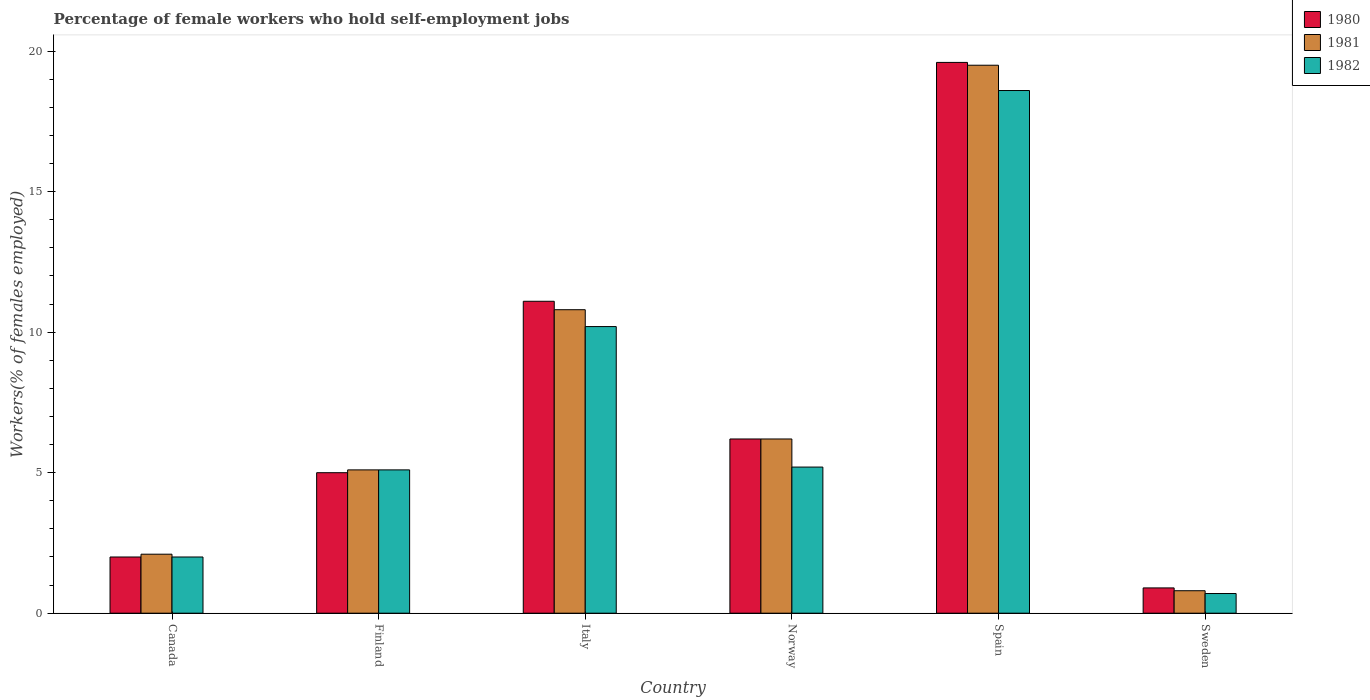How many different coloured bars are there?
Offer a terse response. 3. How many groups of bars are there?
Offer a very short reply. 6. What is the label of the 2nd group of bars from the left?
Your answer should be very brief. Finland. What is the percentage of self-employed female workers in 1982 in Sweden?
Ensure brevity in your answer.  0.7. Across all countries, what is the maximum percentage of self-employed female workers in 1980?
Provide a succinct answer. 19.6. Across all countries, what is the minimum percentage of self-employed female workers in 1982?
Keep it short and to the point. 0.7. In which country was the percentage of self-employed female workers in 1981 maximum?
Your response must be concise. Spain. In which country was the percentage of self-employed female workers in 1980 minimum?
Offer a very short reply. Sweden. What is the total percentage of self-employed female workers in 1982 in the graph?
Your answer should be compact. 41.8. What is the difference between the percentage of self-employed female workers in 1980 in Norway and that in Spain?
Your response must be concise. -13.4. What is the difference between the percentage of self-employed female workers in 1981 in Canada and the percentage of self-employed female workers in 1982 in Finland?
Your answer should be very brief. -3. What is the average percentage of self-employed female workers in 1980 per country?
Offer a terse response. 7.47. What is the difference between the percentage of self-employed female workers of/in 1980 and percentage of self-employed female workers of/in 1981 in Sweden?
Offer a very short reply. 0.1. What is the ratio of the percentage of self-employed female workers in 1980 in Canada to that in Spain?
Keep it short and to the point. 0.1. Is the percentage of self-employed female workers in 1980 in Italy less than that in Spain?
Provide a short and direct response. Yes. What is the difference between the highest and the second highest percentage of self-employed female workers in 1981?
Keep it short and to the point. -8.7. What is the difference between the highest and the lowest percentage of self-employed female workers in 1982?
Offer a very short reply. 17.9. Is the sum of the percentage of self-employed female workers in 1982 in Italy and Spain greater than the maximum percentage of self-employed female workers in 1980 across all countries?
Give a very brief answer. Yes. How many countries are there in the graph?
Provide a short and direct response. 6. Are the values on the major ticks of Y-axis written in scientific E-notation?
Your answer should be very brief. No. Does the graph contain any zero values?
Keep it short and to the point. No. How many legend labels are there?
Offer a terse response. 3. What is the title of the graph?
Provide a succinct answer. Percentage of female workers who hold self-employment jobs. What is the label or title of the Y-axis?
Your response must be concise. Workers(% of females employed). What is the Workers(% of females employed) of 1980 in Canada?
Ensure brevity in your answer.  2. What is the Workers(% of females employed) of 1981 in Canada?
Offer a very short reply. 2.1. What is the Workers(% of females employed) in 1982 in Canada?
Give a very brief answer. 2. What is the Workers(% of females employed) of 1981 in Finland?
Provide a succinct answer. 5.1. What is the Workers(% of females employed) of 1982 in Finland?
Provide a short and direct response. 5.1. What is the Workers(% of females employed) in 1980 in Italy?
Offer a very short reply. 11.1. What is the Workers(% of females employed) of 1981 in Italy?
Keep it short and to the point. 10.8. What is the Workers(% of females employed) of 1982 in Italy?
Provide a succinct answer. 10.2. What is the Workers(% of females employed) in 1980 in Norway?
Give a very brief answer. 6.2. What is the Workers(% of females employed) of 1981 in Norway?
Your response must be concise. 6.2. What is the Workers(% of females employed) in 1982 in Norway?
Keep it short and to the point. 5.2. What is the Workers(% of females employed) in 1980 in Spain?
Ensure brevity in your answer.  19.6. What is the Workers(% of females employed) of 1981 in Spain?
Your response must be concise. 19.5. What is the Workers(% of females employed) in 1982 in Spain?
Provide a succinct answer. 18.6. What is the Workers(% of females employed) of 1980 in Sweden?
Offer a terse response. 0.9. What is the Workers(% of females employed) in 1981 in Sweden?
Provide a short and direct response. 0.8. What is the Workers(% of females employed) in 1982 in Sweden?
Ensure brevity in your answer.  0.7. Across all countries, what is the maximum Workers(% of females employed) in 1980?
Keep it short and to the point. 19.6. Across all countries, what is the maximum Workers(% of females employed) in 1981?
Provide a succinct answer. 19.5. Across all countries, what is the maximum Workers(% of females employed) in 1982?
Your answer should be very brief. 18.6. Across all countries, what is the minimum Workers(% of females employed) in 1980?
Your answer should be compact. 0.9. Across all countries, what is the minimum Workers(% of females employed) of 1981?
Provide a succinct answer. 0.8. Across all countries, what is the minimum Workers(% of females employed) of 1982?
Give a very brief answer. 0.7. What is the total Workers(% of females employed) in 1980 in the graph?
Your answer should be compact. 44.8. What is the total Workers(% of females employed) of 1981 in the graph?
Offer a very short reply. 44.5. What is the total Workers(% of females employed) in 1982 in the graph?
Keep it short and to the point. 41.8. What is the difference between the Workers(% of females employed) of 1980 in Canada and that in Finland?
Your response must be concise. -3. What is the difference between the Workers(% of females employed) of 1982 in Canada and that in Finland?
Provide a short and direct response. -3.1. What is the difference between the Workers(% of females employed) of 1980 in Canada and that in Italy?
Your answer should be compact. -9.1. What is the difference between the Workers(% of females employed) of 1982 in Canada and that in Italy?
Your answer should be compact. -8.2. What is the difference between the Workers(% of females employed) of 1982 in Canada and that in Norway?
Ensure brevity in your answer.  -3.2. What is the difference between the Workers(% of females employed) in 1980 in Canada and that in Spain?
Offer a very short reply. -17.6. What is the difference between the Workers(% of females employed) of 1981 in Canada and that in Spain?
Provide a succinct answer. -17.4. What is the difference between the Workers(% of females employed) of 1982 in Canada and that in Spain?
Give a very brief answer. -16.6. What is the difference between the Workers(% of females employed) in 1980 in Canada and that in Sweden?
Provide a short and direct response. 1.1. What is the difference between the Workers(% of females employed) of 1981 in Canada and that in Sweden?
Provide a short and direct response. 1.3. What is the difference between the Workers(% of females employed) of 1982 in Canada and that in Sweden?
Provide a succinct answer. 1.3. What is the difference between the Workers(% of females employed) of 1980 in Finland and that in Italy?
Provide a succinct answer. -6.1. What is the difference between the Workers(% of females employed) in 1980 in Finland and that in Norway?
Give a very brief answer. -1.2. What is the difference between the Workers(% of females employed) in 1980 in Finland and that in Spain?
Your response must be concise. -14.6. What is the difference between the Workers(% of females employed) of 1981 in Finland and that in Spain?
Give a very brief answer. -14.4. What is the difference between the Workers(% of females employed) of 1982 in Finland and that in Sweden?
Make the answer very short. 4.4. What is the difference between the Workers(% of females employed) of 1980 in Italy and that in Norway?
Keep it short and to the point. 4.9. What is the difference between the Workers(% of females employed) in 1981 in Italy and that in Norway?
Ensure brevity in your answer.  4.6. What is the difference between the Workers(% of females employed) in 1981 in Italy and that in Spain?
Make the answer very short. -8.7. What is the difference between the Workers(% of females employed) of 1982 in Italy and that in Sweden?
Make the answer very short. 9.5. What is the difference between the Workers(% of females employed) of 1981 in Norway and that in Spain?
Offer a terse response. -13.3. What is the difference between the Workers(% of females employed) of 1982 in Norway and that in Spain?
Keep it short and to the point. -13.4. What is the difference between the Workers(% of females employed) of 1980 in Norway and that in Sweden?
Your response must be concise. 5.3. What is the difference between the Workers(% of females employed) of 1981 in Norway and that in Sweden?
Keep it short and to the point. 5.4. What is the difference between the Workers(% of females employed) in 1982 in Norway and that in Sweden?
Give a very brief answer. 4.5. What is the difference between the Workers(% of females employed) in 1982 in Spain and that in Sweden?
Keep it short and to the point. 17.9. What is the difference between the Workers(% of females employed) of 1980 in Canada and the Workers(% of females employed) of 1982 in Finland?
Your answer should be compact. -3.1. What is the difference between the Workers(% of females employed) in 1981 in Canada and the Workers(% of females employed) in 1982 in Finland?
Give a very brief answer. -3. What is the difference between the Workers(% of females employed) of 1980 in Canada and the Workers(% of females employed) of 1981 in Italy?
Your response must be concise. -8.8. What is the difference between the Workers(% of females employed) of 1980 in Canada and the Workers(% of females employed) of 1982 in Italy?
Ensure brevity in your answer.  -8.2. What is the difference between the Workers(% of females employed) in 1981 in Canada and the Workers(% of females employed) in 1982 in Italy?
Ensure brevity in your answer.  -8.1. What is the difference between the Workers(% of females employed) of 1980 in Canada and the Workers(% of females employed) of 1981 in Norway?
Ensure brevity in your answer.  -4.2. What is the difference between the Workers(% of females employed) in 1980 in Canada and the Workers(% of females employed) in 1982 in Norway?
Provide a succinct answer. -3.2. What is the difference between the Workers(% of females employed) in 1980 in Canada and the Workers(% of females employed) in 1981 in Spain?
Keep it short and to the point. -17.5. What is the difference between the Workers(% of females employed) of 1980 in Canada and the Workers(% of females employed) of 1982 in Spain?
Your answer should be compact. -16.6. What is the difference between the Workers(% of females employed) of 1981 in Canada and the Workers(% of females employed) of 1982 in Spain?
Provide a succinct answer. -16.5. What is the difference between the Workers(% of females employed) in 1981 in Canada and the Workers(% of females employed) in 1982 in Sweden?
Offer a very short reply. 1.4. What is the difference between the Workers(% of females employed) in 1980 in Finland and the Workers(% of females employed) in 1981 in Italy?
Your answer should be compact. -5.8. What is the difference between the Workers(% of females employed) in 1981 in Finland and the Workers(% of females employed) in 1982 in Italy?
Provide a short and direct response. -5.1. What is the difference between the Workers(% of females employed) of 1980 in Finland and the Workers(% of females employed) of 1982 in Spain?
Your answer should be compact. -13.6. What is the difference between the Workers(% of females employed) of 1981 in Finland and the Workers(% of females employed) of 1982 in Spain?
Ensure brevity in your answer.  -13.5. What is the difference between the Workers(% of females employed) of 1980 in Finland and the Workers(% of females employed) of 1982 in Sweden?
Keep it short and to the point. 4.3. What is the difference between the Workers(% of females employed) in 1981 in Finland and the Workers(% of females employed) in 1982 in Sweden?
Ensure brevity in your answer.  4.4. What is the difference between the Workers(% of females employed) of 1980 in Italy and the Workers(% of females employed) of 1981 in Norway?
Give a very brief answer. 4.9. What is the difference between the Workers(% of females employed) of 1980 in Italy and the Workers(% of females employed) of 1982 in Spain?
Provide a succinct answer. -7.5. What is the difference between the Workers(% of females employed) in 1981 in Italy and the Workers(% of females employed) in 1982 in Spain?
Your answer should be very brief. -7.8. What is the difference between the Workers(% of females employed) of 1980 in Italy and the Workers(% of females employed) of 1981 in Sweden?
Offer a terse response. 10.3. What is the difference between the Workers(% of females employed) of 1980 in Italy and the Workers(% of females employed) of 1982 in Sweden?
Provide a short and direct response. 10.4. What is the difference between the Workers(% of females employed) in 1981 in Italy and the Workers(% of females employed) in 1982 in Sweden?
Your answer should be compact. 10.1. What is the difference between the Workers(% of females employed) in 1980 in Norway and the Workers(% of females employed) in 1981 in Spain?
Give a very brief answer. -13.3. What is the difference between the Workers(% of females employed) in 1980 in Norway and the Workers(% of females employed) in 1982 in Spain?
Make the answer very short. -12.4. What is the difference between the Workers(% of females employed) of 1980 in Spain and the Workers(% of females employed) of 1981 in Sweden?
Give a very brief answer. 18.8. What is the difference between the Workers(% of females employed) in 1981 in Spain and the Workers(% of females employed) in 1982 in Sweden?
Make the answer very short. 18.8. What is the average Workers(% of females employed) of 1980 per country?
Offer a very short reply. 7.47. What is the average Workers(% of females employed) in 1981 per country?
Your response must be concise. 7.42. What is the average Workers(% of females employed) in 1982 per country?
Offer a very short reply. 6.97. What is the difference between the Workers(% of females employed) in 1980 and Workers(% of females employed) in 1982 in Canada?
Give a very brief answer. 0. What is the difference between the Workers(% of females employed) in 1981 and Workers(% of females employed) in 1982 in Canada?
Keep it short and to the point. 0.1. What is the difference between the Workers(% of females employed) in 1981 and Workers(% of females employed) in 1982 in Italy?
Your response must be concise. 0.6. What is the difference between the Workers(% of females employed) of 1980 and Workers(% of females employed) of 1981 in Norway?
Provide a succinct answer. 0. What is the difference between the Workers(% of females employed) in 1980 and Workers(% of females employed) in 1982 in Norway?
Your answer should be compact. 1. What is the difference between the Workers(% of females employed) of 1981 and Workers(% of females employed) of 1982 in Norway?
Ensure brevity in your answer.  1. What is the difference between the Workers(% of females employed) of 1980 and Workers(% of females employed) of 1982 in Spain?
Offer a terse response. 1. What is the difference between the Workers(% of females employed) of 1981 and Workers(% of females employed) of 1982 in Spain?
Keep it short and to the point. 0.9. What is the difference between the Workers(% of females employed) of 1980 and Workers(% of females employed) of 1982 in Sweden?
Your response must be concise. 0.2. What is the difference between the Workers(% of females employed) in 1981 and Workers(% of females employed) in 1982 in Sweden?
Keep it short and to the point. 0.1. What is the ratio of the Workers(% of females employed) in 1981 in Canada to that in Finland?
Provide a succinct answer. 0.41. What is the ratio of the Workers(% of females employed) of 1982 in Canada to that in Finland?
Your response must be concise. 0.39. What is the ratio of the Workers(% of females employed) in 1980 in Canada to that in Italy?
Offer a very short reply. 0.18. What is the ratio of the Workers(% of females employed) of 1981 in Canada to that in Italy?
Provide a succinct answer. 0.19. What is the ratio of the Workers(% of females employed) of 1982 in Canada to that in Italy?
Provide a short and direct response. 0.2. What is the ratio of the Workers(% of females employed) in 1980 in Canada to that in Norway?
Make the answer very short. 0.32. What is the ratio of the Workers(% of females employed) of 1981 in Canada to that in Norway?
Provide a succinct answer. 0.34. What is the ratio of the Workers(% of females employed) of 1982 in Canada to that in Norway?
Offer a very short reply. 0.38. What is the ratio of the Workers(% of females employed) of 1980 in Canada to that in Spain?
Offer a terse response. 0.1. What is the ratio of the Workers(% of females employed) of 1981 in Canada to that in Spain?
Provide a short and direct response. 0.11. What is the ratio of the Workers(% of females employed) in 1982 in Canada to that in Spain?
Make the answer very short. 0.11. What is the ratio of the Workers(% of females employed) of 1980 in Canada to that in Sweden?
Give a very brief answer. 2.22. What is the ratio of the Workers(% of females employed) in 1981 in Canada to that in Sweden?
Your response must be concise. 2.62. What is the ratio of the Workers(% of females employed) in 1982 in Canada to that in Sweden?
Your answer should be compact. 2.86. What is the ratio of the Workers(% of females employed) of 1980 in Finland to that in Italy?
Make the answer very short. 0.45. What is the ratio of the Workers(% of females employed) in 1981 in Finland to that in Italy?
Provide a succinct answer. 0.47. What is the ratio of the Workers(% of females employed) of 1980 in Finland to that in Norway?
Provide a short and direct response. 0.81. What is the ratio of the Workers(% of females employed) in 1981 in Finland to that in Norway?
Provide a succinct answer. 0.82. What is the ratio of the Workers(% of females employed) in 1982 in Finland to that in Norway?
Offer a terse response. 0.98. What is the ratio of the Workers(% of females employed) of 1980 in Finland to that in Spain?
Keep it short and to the point. 0.26. What is the ratio of the Workers(% of females employed) of 1981 in Finland to that in Spain?
Your response must be concise. 0.26. What is the ratio of the Workers(% of females employed) of 1982 in Finland to that in Spain?
Your response must be concise. 0.27. What is the ratio of the Workers(% of females employed) in 1980 in Finland to that in Sweden?
Offer a very short reply. 5.56. What is the ratio of the Workers(% of females employed) of 1981 in Finland to that in Sweden?
Ensure brevity in your answer.  6.38. What is the ratio of the Workers(% of females employed) in 1982 in Finland to that in Sweden?
Your answer should be compact. 7.29. What is the ratio of the Workers(% of females employed) in 1980 in Italy to that in Norway?
Ensure brevity in your answer.  1.79. What is the ratio of the Workers(% of females employed) in 1981 in Italy to that in Norway?
Your response must be concise. 1.74. What is the ratio of the Workers(% of females employed) in 1982 in Italy to that in Norway?
Keep it short and to the point. 1.96. What is the ratio of the Workers(% of females employed) in 1980 in Italy to that in Spain?
Provide a succinct answer. 0.57. What is the ratio of the Workers(% of females employed) of 1981 in Italy to that in Spain?
Make the answer very short. 0.55. What is the ratio of the Workers(% of females employed) of 1982 in Italy to that in Spain?
Provide a short and direct response. 0.55. What is the ratio of the Workers(% of females employed) in 1980 in Italy to that in Sweden?
Provide a short and direct response. 12.33. What is the ratio of the Workers(% of females employed) in 1981 in Italy to that in Sweden?
Give a very brief answer. 13.5. What is the ratio of the Workers(% of females employed) of 1982 in Italy to that in Sweden?
Make the answer very short. 14.57. What is the ratio of the Workers(% of females employed) in 1980 in Norway to that in Spain?
Give a very brief answer. 0.32. What is the ratio of the Workers(% of females employed) in 1981 in Norway to that in Spain?
Provide a short and direct response. 0.32. What is the ratio of the Workers(% of females employed) of 1982 in Norway to that in Spain?
Offer a very short reply. 0.28. What is the ratio of the Workers(% of females employed) in 1980 in Norway to that in Sweden?
Ensure brevity in your answer.  6.89. What is the ratio of the Workers(% of females employed) in 1981 in Norway to that in Sweden?
Give a very brief answer. 7.75. What is the ratio of the Workers(% of females employed) in 1982 in Norway to that in Sweden?
Give a very brief answer. 7.43. What is the ratio of the Workers(% of females employed) in 1980 in Spain to that in Sweden?
Provide a succinct answer. 21.78. What is the ratio of the Workers(% of females employed) of 1981 in Spain to that in Sweden?
Offer a terse response. 24.38. What is the ratio of the Workers(% of females employed) of 1982 in Spain to that in Sweden?
Ensure brevity in your answer.  26.57. What is the difference between the highest and the second highest Workers(% of females employed) of 1981?
Your answer should be very brief. 8.7. What is the difference between the highest and the second highest Workers(% of females employed) in 1982?
Provide a short and direct response. 8.4. What is the difference between the highest and the lowest Workers(% of females employed) of 1981?
Keep it short and to the point. 18.7. What is the difference between the highest and the lowest Workers(% of females employed) in 1982?
Keep it short and to the point. 17.9. 